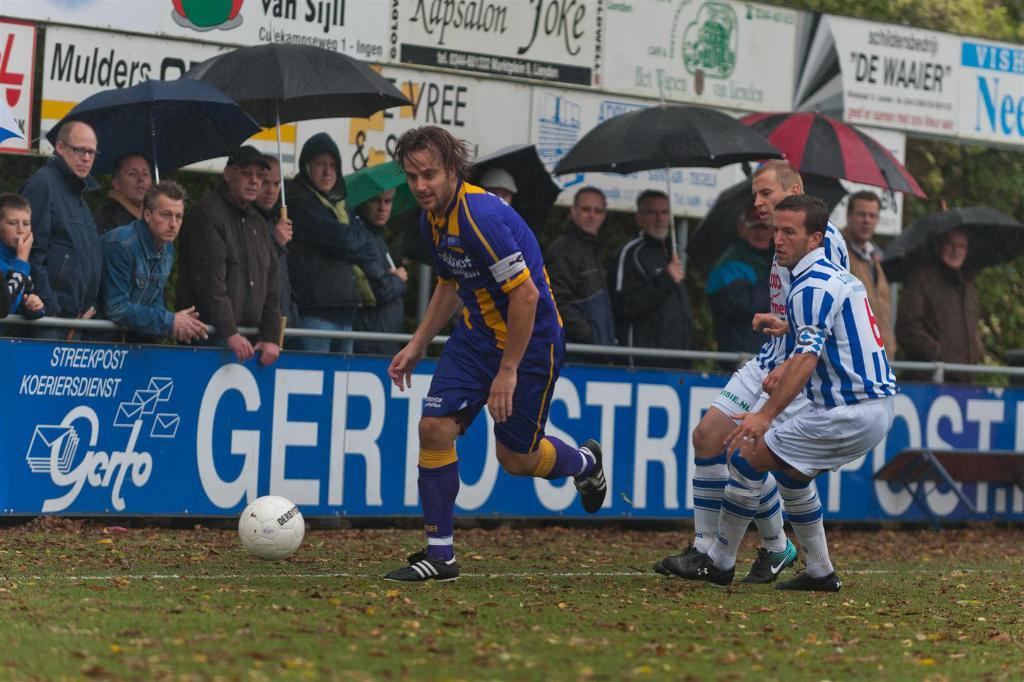<image>
Provide a brief description of the given image. A soccer game in the rain in front of a Streekopst Koeriersdienst advertising board. 